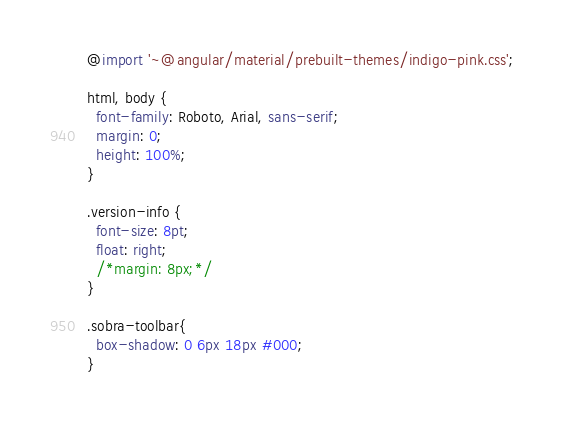Convert code to text. <code><loc_0><loc_0><loc_500><loc_500><_CSS_>@import '~@angular/material/prebuilt-themes/indigo-pink.css';

html, body {
  font-family: Roboto, Arial, sans-serif;
  margin: 0;
  height: 100%;
}

.version-info {
  font-size: 8pt;
  float: right;
  /*margin: 8px;*/
}

.sobra-toolbar{
  box-shadow: 0 6px 18px #000;
}
</code> 